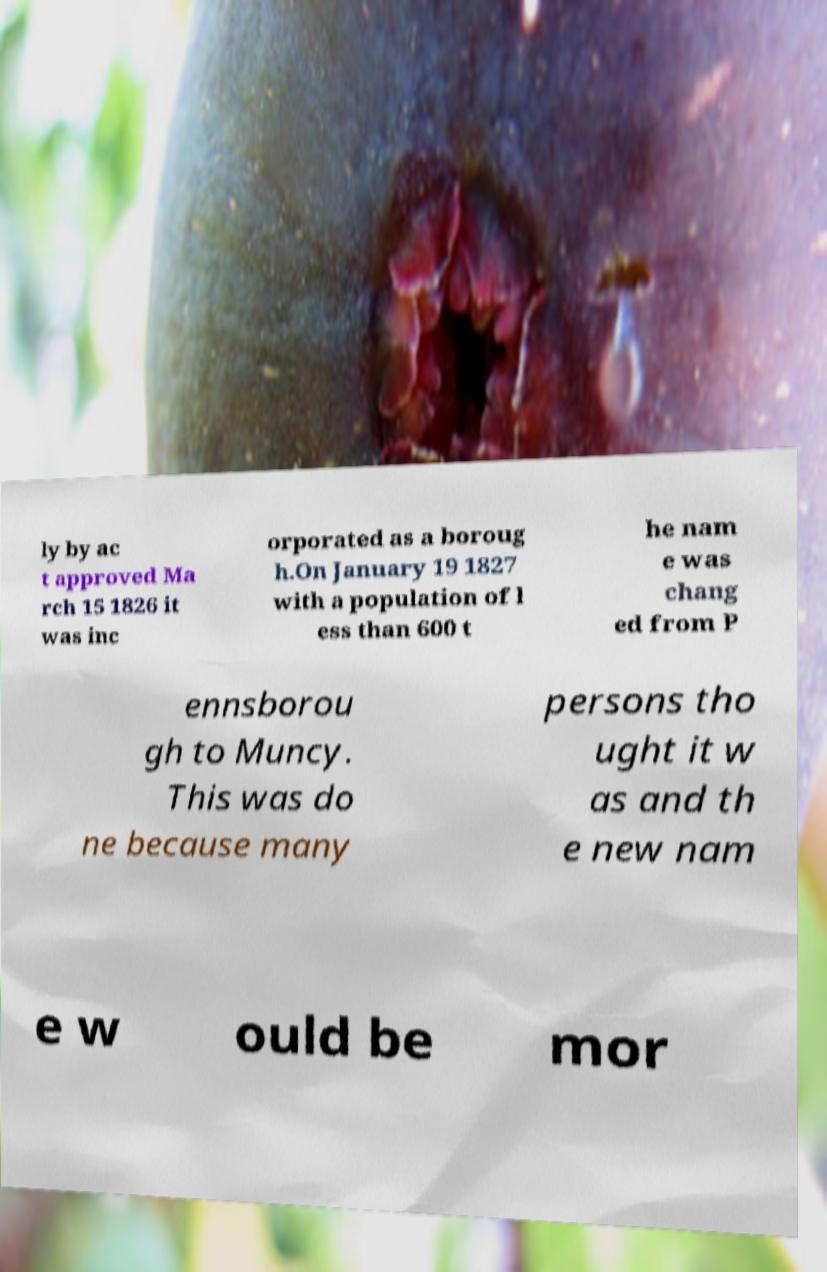Could you extract and type out the text from this image? ly by ac t approved Ma rch 15 1826 it was inc orporated as a boroug h.On January 19 1827 with a population of l ess than 600 t he nam e was chang ed from P ennsborou gh to Muncy. This was do ne because many persons tho ught it w as and th e new nam e w ould be mor 